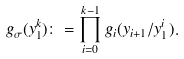<formula> <loc_0><loc_0><loc_500><loc_500>g _ { \sigma } ( y _ { 1 } ^ { k } ) \colon = \prod _ { i = 0 } ^ { k - 1 } g _ { i } ( y _ { i + 1 } / y _ { 1 } ^ { i } ) .</formula> 